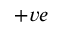<formula> <loc_0><loc_0><loc_500><loc_500>+ v e</formula> 